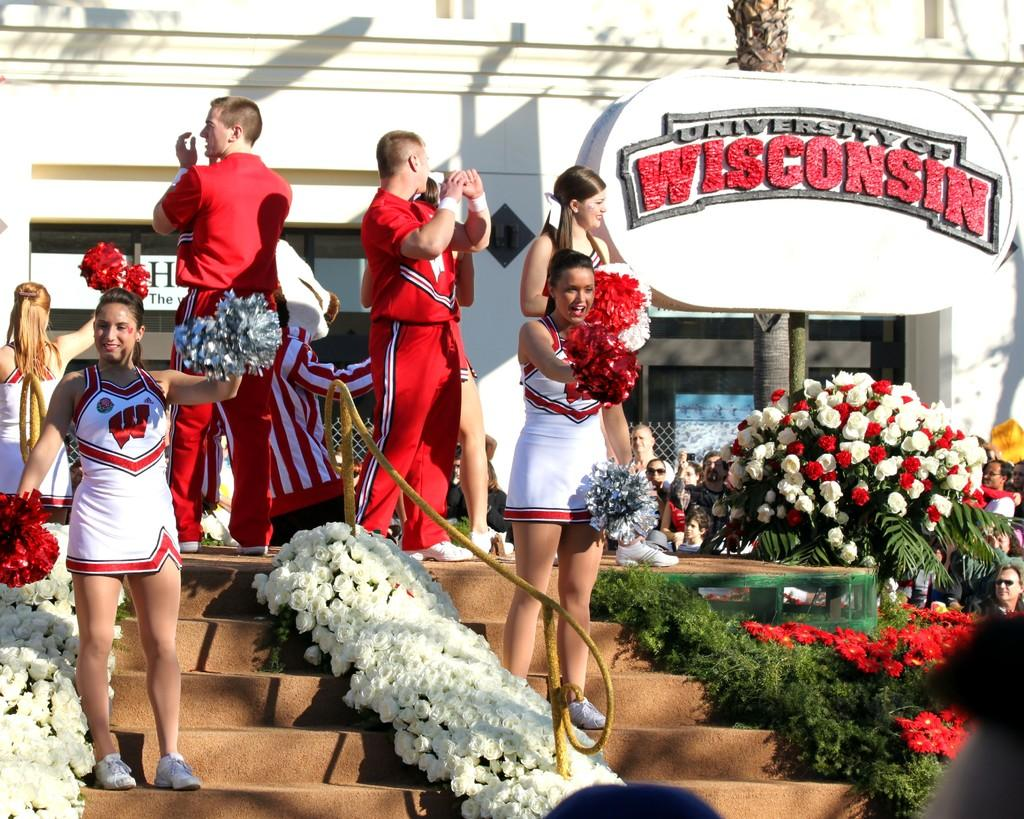<image>
Provide a brief description of the given image. Several male and female cheerleaders are cheering on a set of stairs, in front of a large sign for the University Of Wisconsin. 